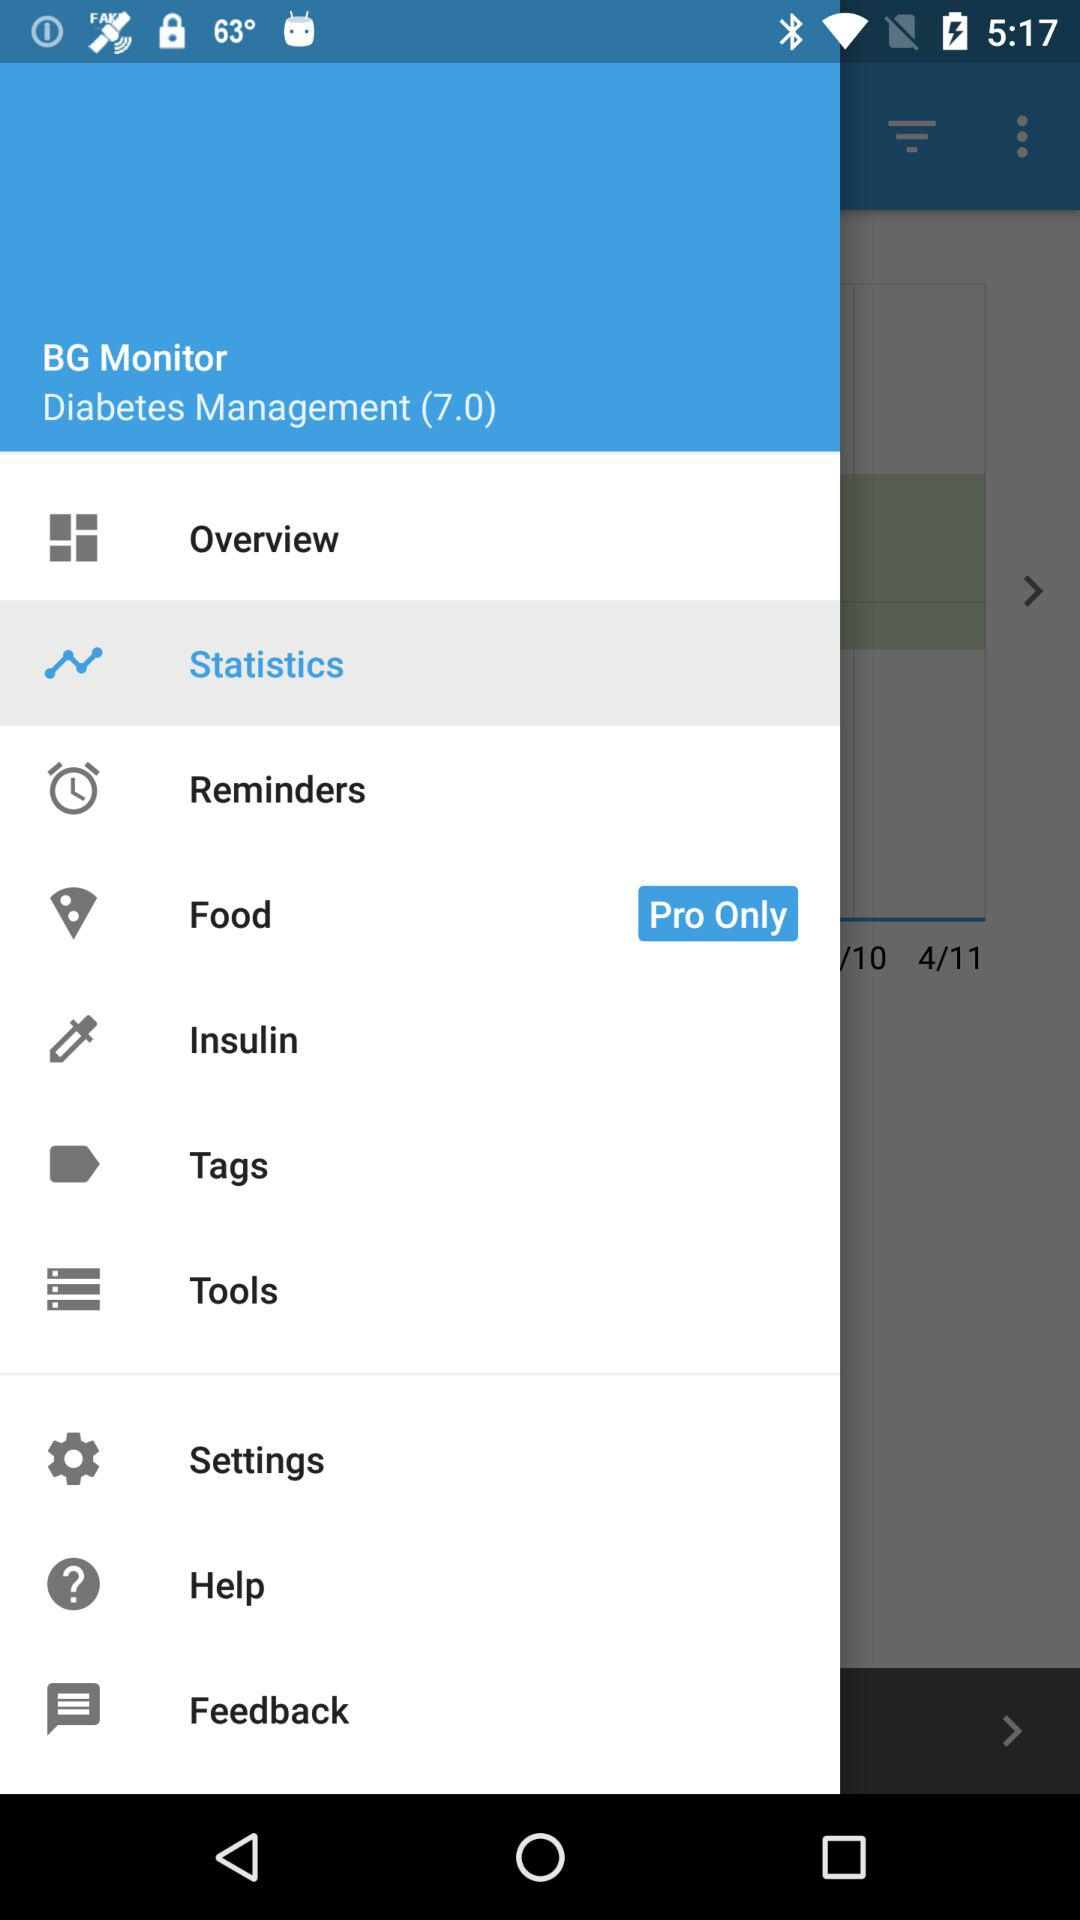How much is the insulin dosage?
When the provided information is insufficient, respond with <no answer>. <no answer> 